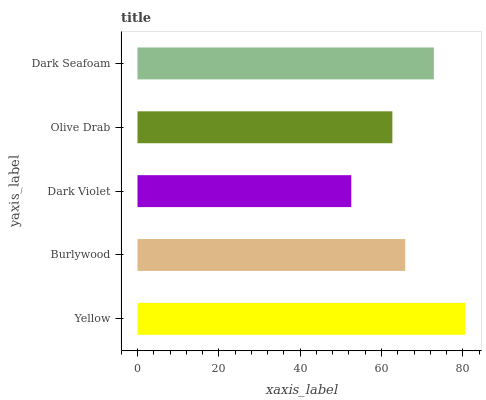Is Dark Violet the minimum?
Answer yes or no. Yes. Is Yellow the maximum?
Answer yes or no. Yes. Is Burlywood the minimum?
Answer yes or no. No. Is Burlywood the maximum?
Answer yes or no. No. Is Yellow greater than Burlywood?
Answer yes or no. Yes. Is Burlywood less than Yellow?
Answer yes or no. Yes. Is Burlywood greater than Yellow?
Answer yes or no. No. Is Yellow less than Burlywood?
Answer yes or no. No. Is Burlywood the high median?
Answer yes or no. Yes. Is Burlywood the low median?
Answer yes or no. Yes. Is Dark Violet the high median?
Answer yes or no. No. Is Dark Seafoam the low median?
Answer yes or no. No. 